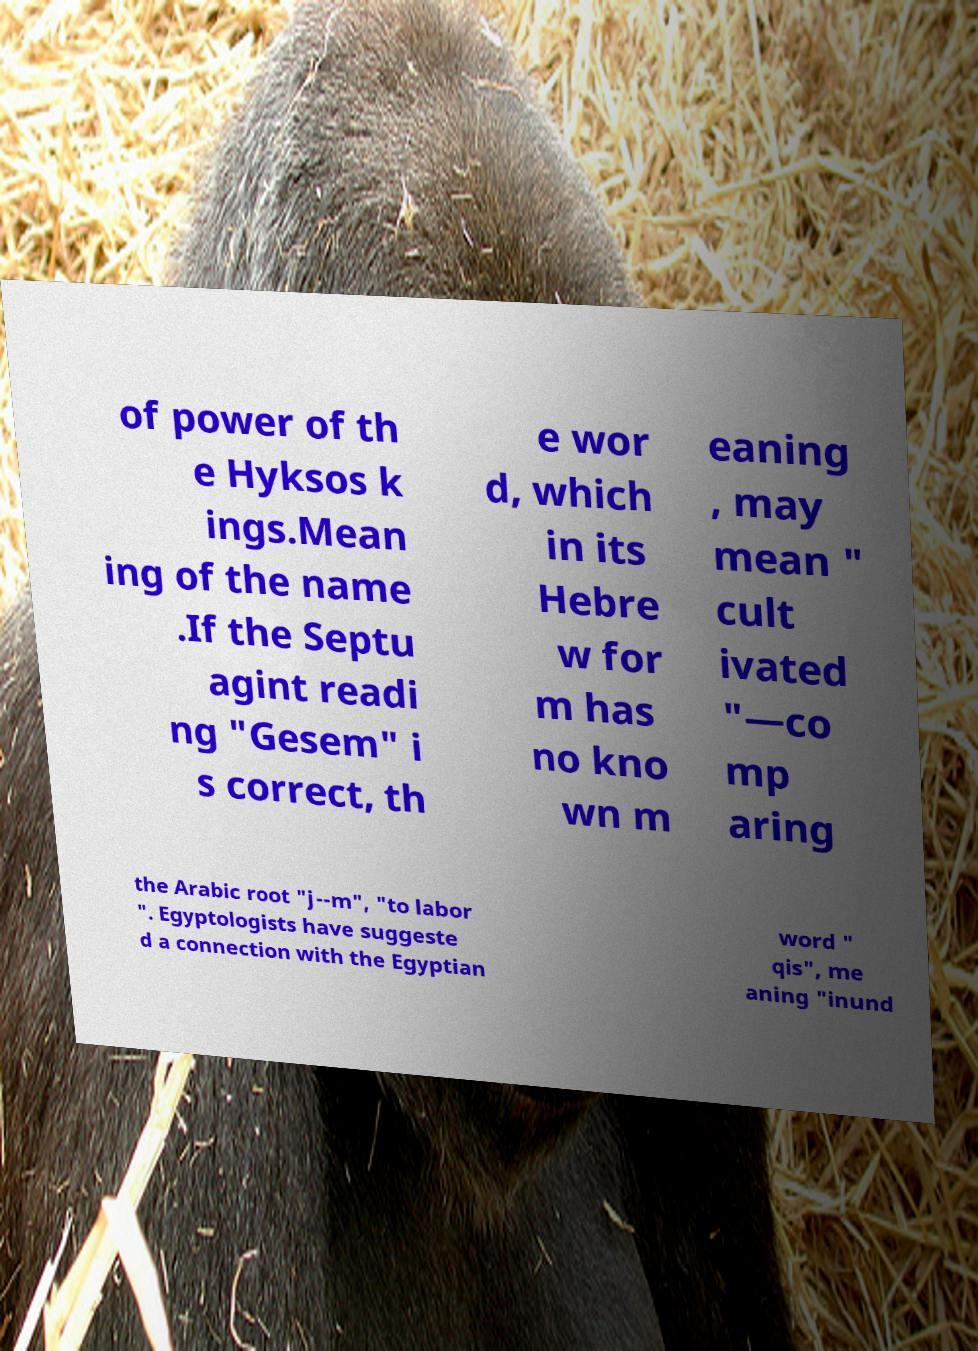Could you assist in decoding the text presented in this image and type it out clearly? of power of th e Hyksos k ings.Mean ing of the name .If the Septu agint readi ng "Gesem" i s correct, th e wor d, which in its Hebre w for m has no kno wn m eaning , may mean " cult ivated "—co mp aring the Arabic root "j--m", "to labor ". Egyptologists have suggeste d a connection with the Egyptian word " qis", me aning "inund 